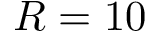Convert formula to latex. <formula><loc_0><loc_0><loc_500><loc_500>R = 1 0</formula> 